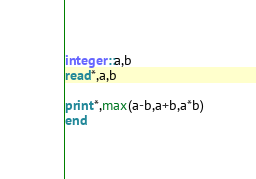Convert code to text. <code><loc_0><loc_0><loc_500><loc_500><_FORTRAN_>integer::a,b
read*,a,b

print*,max(a-b,a+b,a*b)
end
</code> 